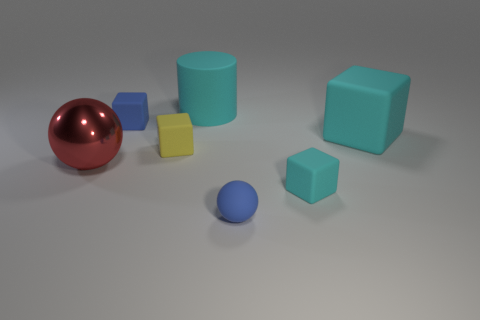There is a large rubber cylinder; is its color the same as the large rubber object in front of the small blue matte block? Yes, the large rubber cylinder shares the same teal color as the large rubber cube positioned in front of the small blue matte block. The shared color creates a visual harmony among the objects within the scene. 